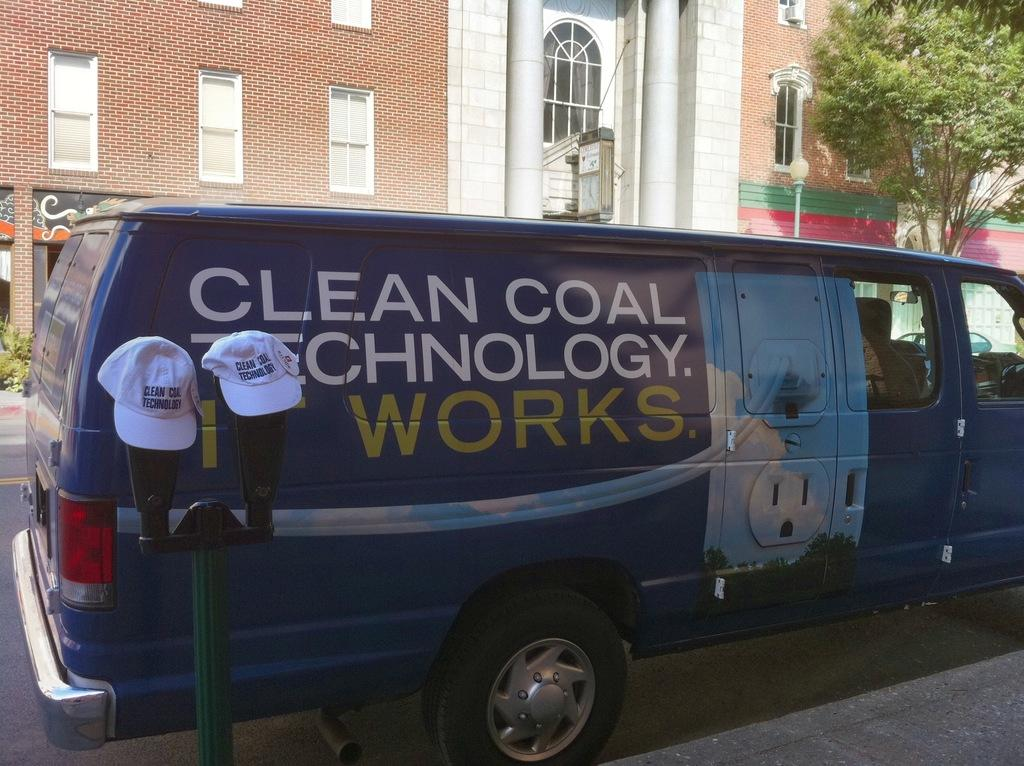What type of vehicle is in the image? There is a blue van in the image. Where is the van located? The van is on the road. What can be seen on the left side of the image? There is a pole on the left side of the image, with two white caps visible on it. What is visible in the background of the image? There is a building and a tree in the background of the image. Can you see a maid cleaning the window in the image? There is no window or maid present in the image. 